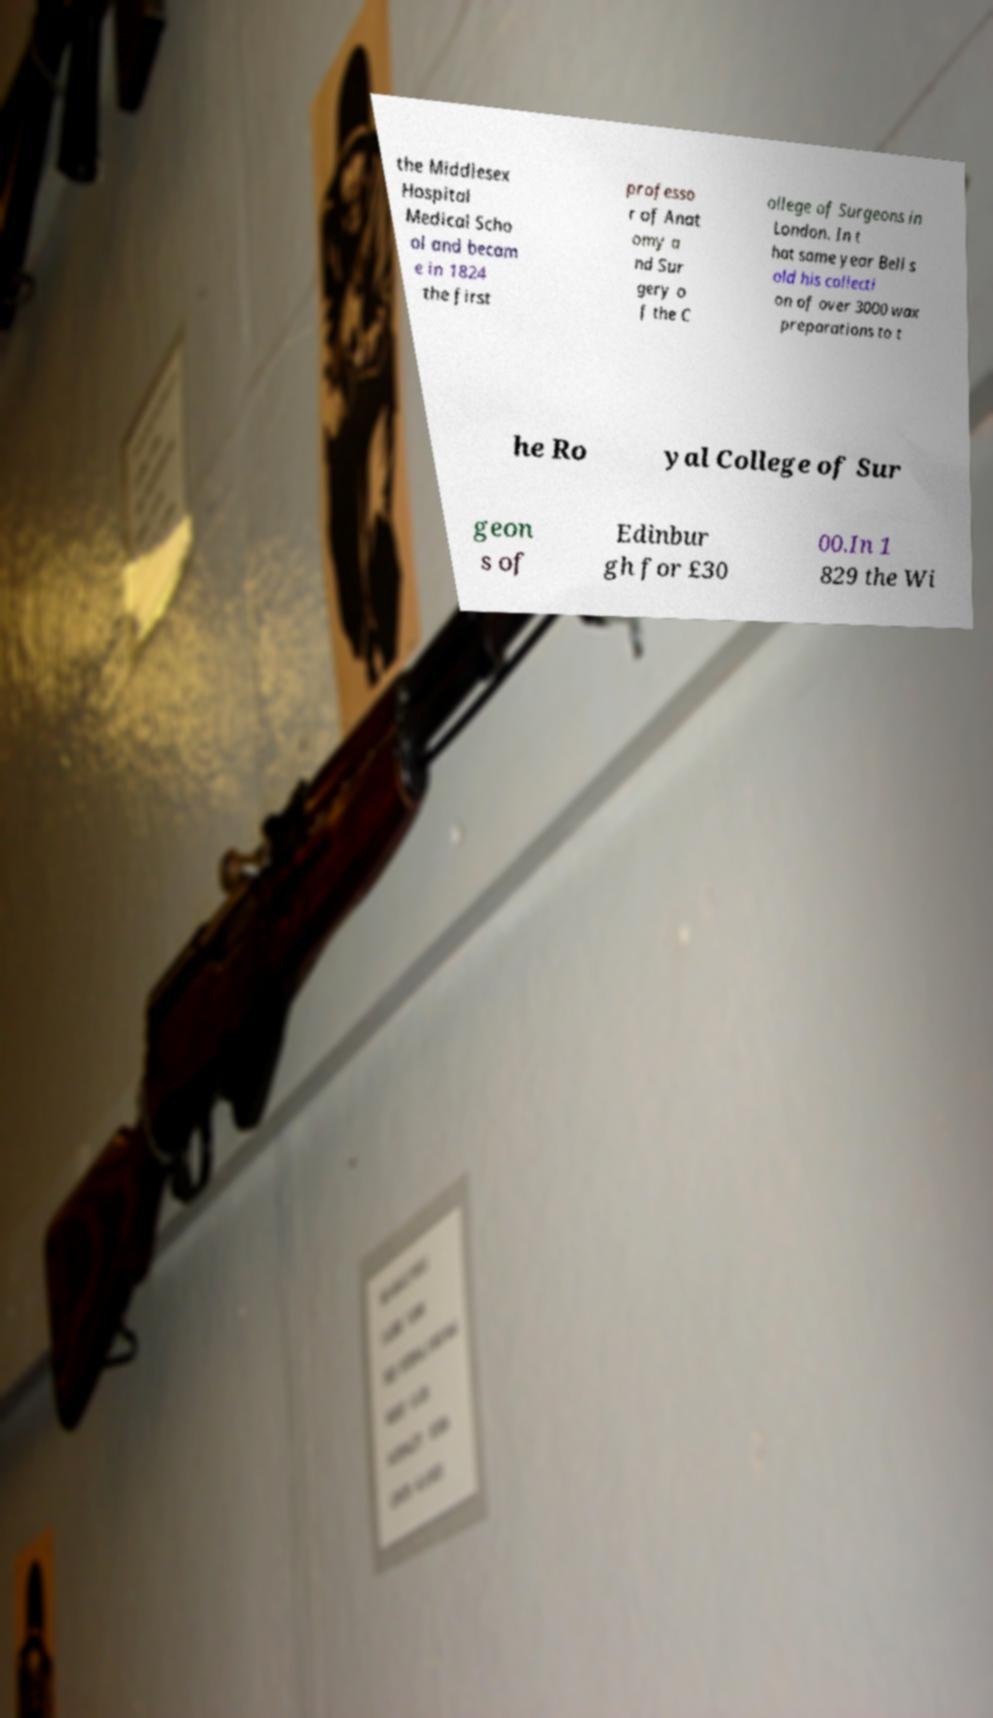Can you accurately transcribe the text from the provided image for me? the Middlesex Hospital Medical Scho ol and becam e in 1824 the first professo r of Anat omy a nd Sur gery o f the C ollege of Surgeons in London. In t hat same year Bell s old his collecti on of over 3000 wax preparations to t he Ro yal College of Sur geon s of Edinbur gh for £30 00.In 1 829 the Wi 